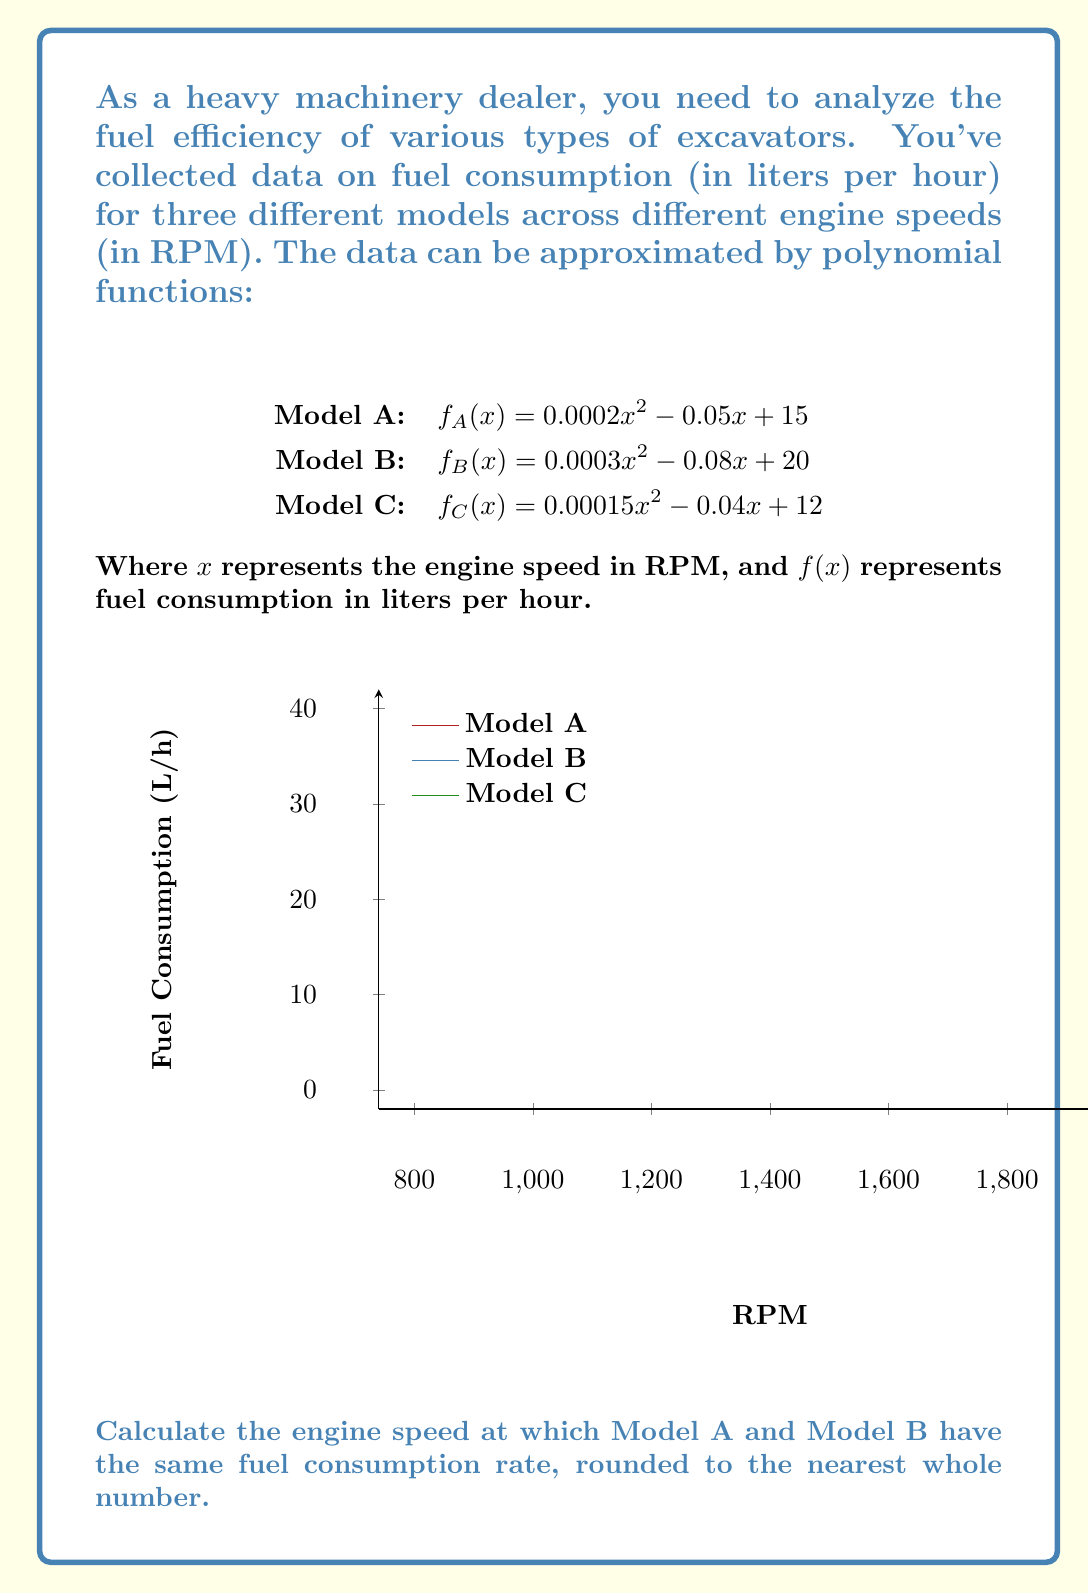Provide a solution to this math problem. To find the engine speed where Model A and Model B have the same fuel consumption, we need to set their functions equal to each other and solve for x:

$$f_A(x) = f_B(x)$$
$$(0.0002x^2 - 0.05x + 15) = (0.0003x^2 - 0.08x + 20)$$

Rearranging the equation:
$$0.0002x^2 - 0.05x + 15 - 0.0003x^2 + 0.08x - 20 = 0$$

Simplifying:
$$-0.0001x^2 + 0.03x - 5 = 0$$

Multiplying all terms by -10000 to eliminate decimals:
$$x^2 - 300x + 50000 = 0$$

This is a quadratic equation in the form $ax^2 + bx + c = 0$, where:
$a = 1$, $b = -300$, and $c = 50000$

We can solve this using the quadratic formula: $x = \frac{-b \pm \sqrt{b^2 - 4ac}}{2a}$

$$x = \frac{300 \pm \sqrt{(-300)^2 - 4(1)(50000)}}{2(1)}$$
$$x = \frac{300 \pm \sqrt{90000 - 200000}}{2}$$
$$x = \frac{300 \pm \sqrt{-110000}}{2}$$

Since the discriminant is negative, there are no real solutions. This means the fuel consumption curves of Model A and Model B never intersect.

However, they come closest at the vertex of the parabola formed by their difference. We can find this point by using the formula $x = -\frac{b}{2a}$ for the axis of symmetry:

$$x = -\frac{-300}{2(1)} = 150$$

Rounding to the nearest whole number, we get 150 RPM.
Answer: 150 RPM 